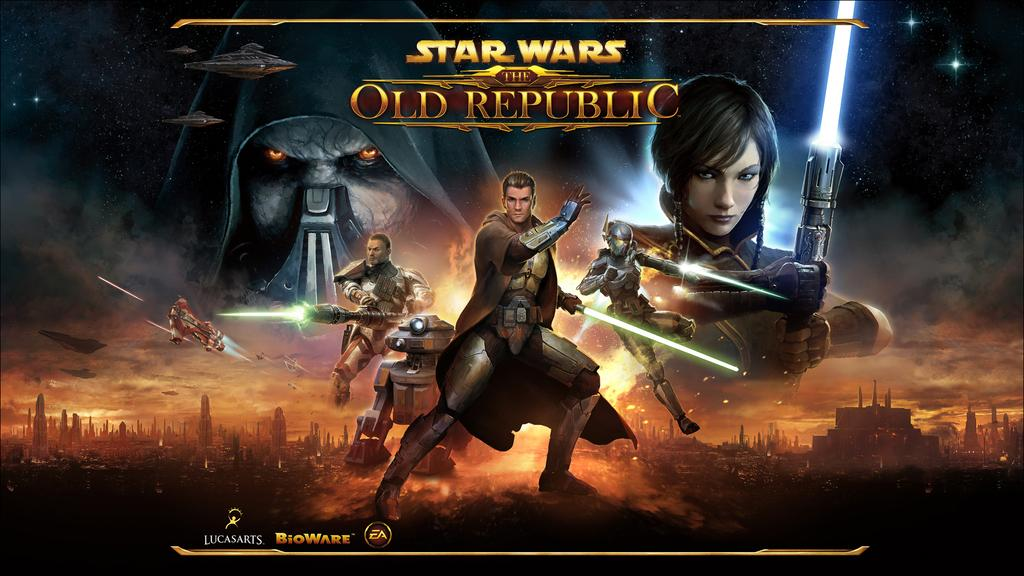Provide a one-sentence caption for the provided image. A poster depicts an outerspace scene featuring characters from a Star Wars video game called The Old Republic. 